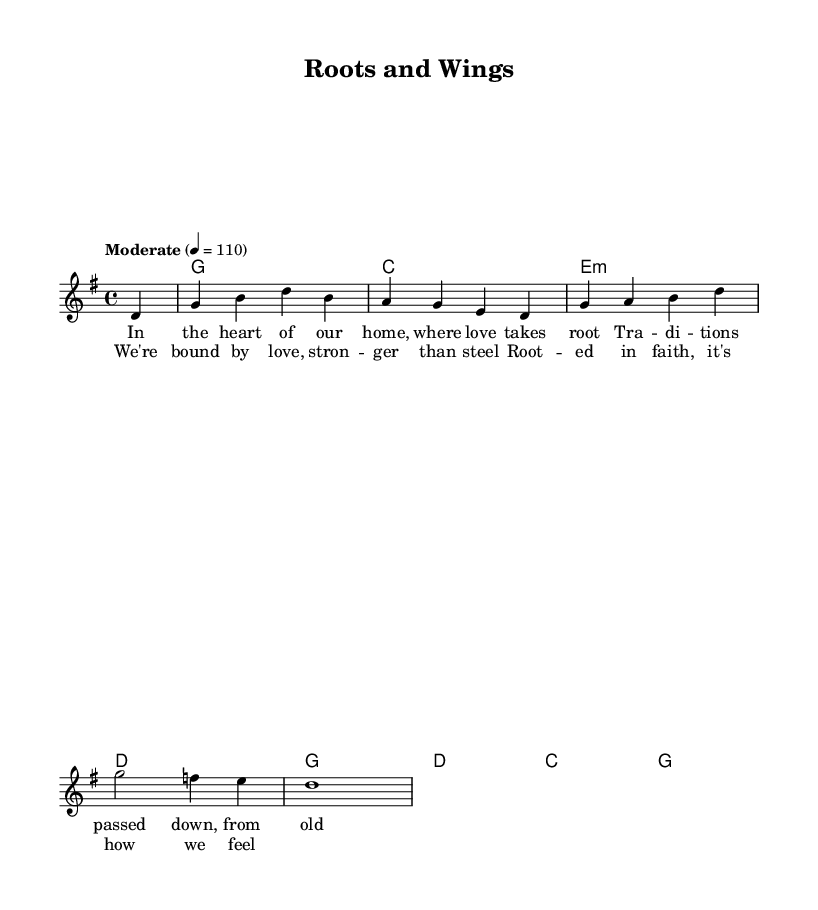What is the key signature of this music? The key signature is G major, which contains one sharp (F#). This can be found at the beginning of the music score, where the key signature is indicated.
Answer: G major What is the time signature of this music? The time signature is 4/4, visible at the beginning of the score. This means there are four beats per measure and the quarter note gets the beat.
Answer: 4/4 What is the tempo marking of this music? The tempo marking is "Moderate," set at 110 beats per minute. This is indicated right after the time signature and tells the performer how quickly to play the piece.
Answer: Moderate How many measures are in the melody? There are eight measures in the melody, which can be counted by looking at the bar lines in the melody section. Each section separated by a vertical line represents one measure.
Answer: Eight What do the lyrics in the verse reflect about family values? The lyrics discuss love and tradition, emphasizing the importance of passing down values from generation to generation. This can be inferred from phrases like "where love takes root" and "traditions passed down."
Answer: Love and tradition What is the primary theme of the chorus? The primary theme of the chorus is unity through love and faith, as expressed in the lines "We're bound by love" and "Rooted in faith." It reflects the essence of family values and togetherness.
Answer: Unity through love and faith 